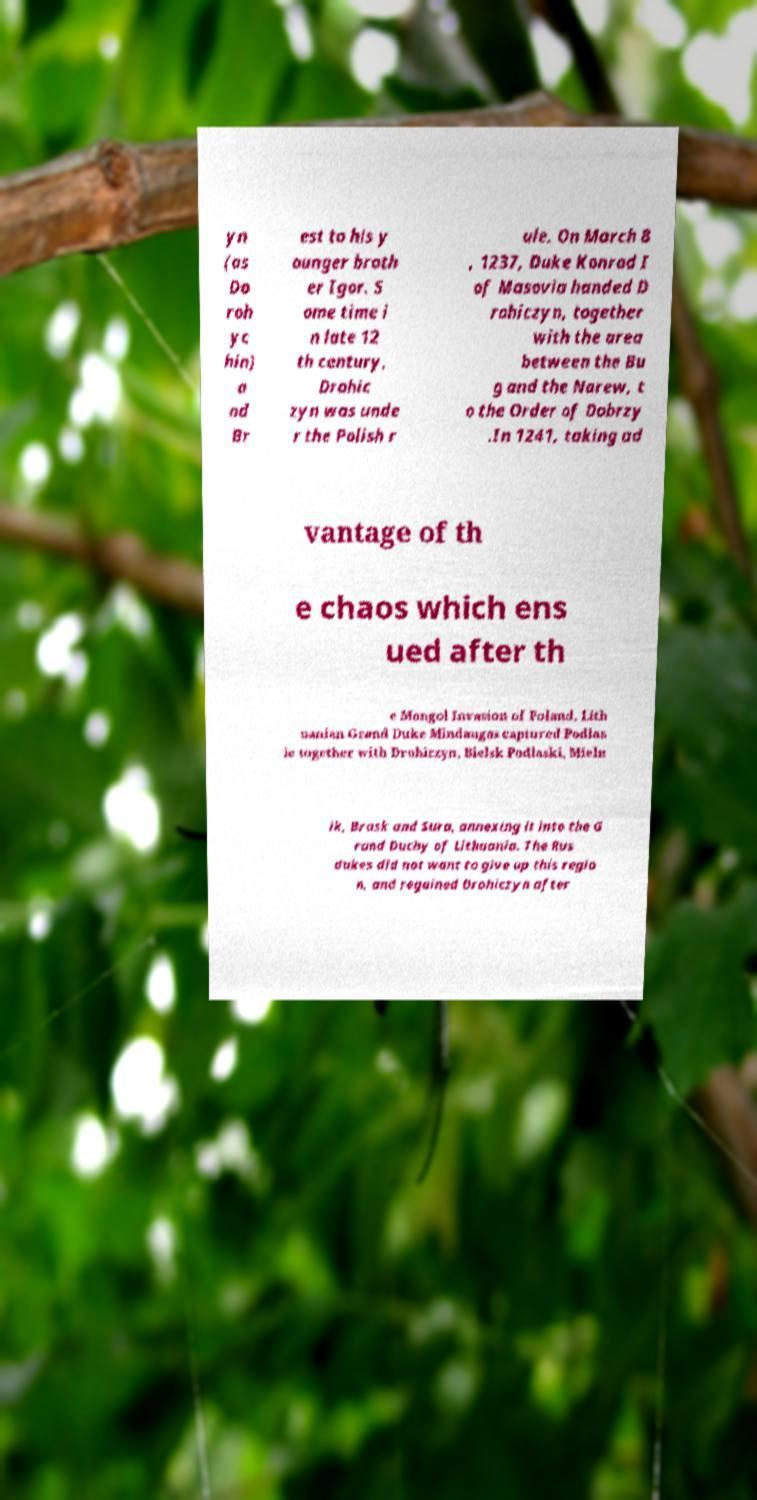I need the written content from this picture converted into text. Can you do that? yn (as Do roh yc hin) a nd Br est to his y ounger broth er Igor. S ome time i n late 12 th century, Drohic zyn was unde r the Polish r ule. On March 8 , 1237, Duke Konrad I of Masovia handed D rohiczyn, together with the area between the Bu g and the Narew, t o the Order of Dobrzy .In 1241, taking ad vantage of th e chaos which ens ued after th e Mongol Invasion of Poland, Lith uanian Grand Duke Mindaugas captured Podlas ie together with Drohiczyn, Bielsk Podlaski, Mieln ik, Brask and Sura, annexing it into the G rand Duchy of Lithuania. The Rus dukes did not want to give up this regio n, and regained Drohiczyn after 